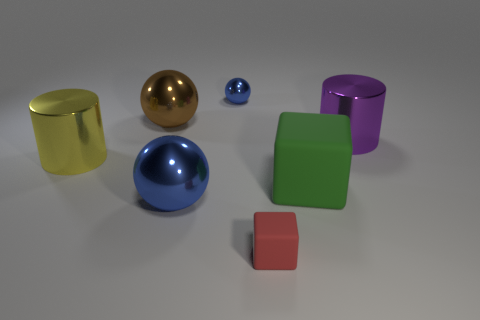Subtract all big metallic spheres. How many spheres are left? 1 Add 3 large yellow blocks. How many objects exist? 10 Subtract 2 cylinders. How many cylinders are left? 0 Subtract all spheres. How many objects are left? 4 Subtract all big blue matte cylinders. Subtract all red blocks. How many objects are left? 6 Add 3 big rubber objects. How many big rubber objects are left? 4 Add 1 small blue rubber cylinders. How many small blue rubber cylinders exist? 1 Subtract all purple cylinders. How many cylinders are left? 1 Subtract 1 green blocks. How many objects are left? 6 Subtract all red cylinders. Subtract all cyan spheres. How many cylinders are left? 2 